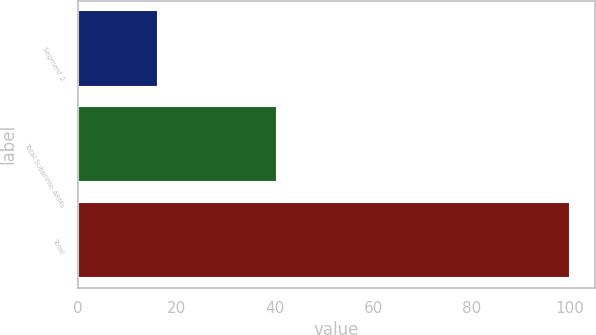<chart> <loc_0><loc_0><loc_500><loc_500><bar_chart><fcel>Segment 2<fcel>Total Subprime ARMs<fcel>Total<nl><fcel>16.2<fcel>40.5<fcel>100<nl></chart> 